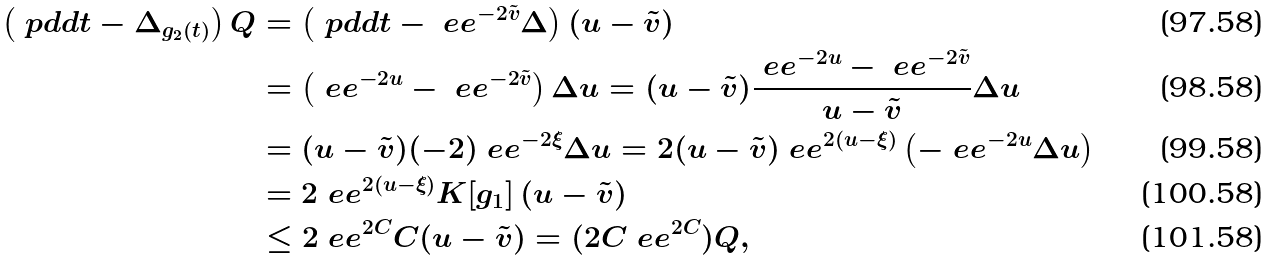<formula> <loc_0><loc_0><loc_500><loc_500>\left ( \ p d d t - \Delta _ { g _ { 2 } ( t ) } \right ) Q & = \left ( \ p d d t - \ e e ^ { - 2 \tilde { v } } \Delta \right ) ( u - \tilde { v } ) \\ & = \left ( \ e e ^ { - 2 u } - \ e e ^ { - 2 \tilde { v } } \right ) \Delta u = ( u - \tilde { v } ) \frac { \ e e ^ { - 2 u } - \ e e ^ { - 2 \tilde { v } } } { u - \tilde { v } } \Delta u \\ & = ( u - \tilde { v } ) ( - 2 ) \ e e ^ { - 2 \xi } \Delta u = 2 ( u - \tilde { v } ) \ e e ^ { 2 ( u - \xi ) } \left ( - \ e e ^ { - 2 u } \Delta u \right ) \\ & = 2 \ e e ^ { 2 ( u - \xi ) } K [ g _ { 1 } ] \, ( u - \tilde { v } ) \\ & \leq 2 \ e e ^ { 2 C } C ( u - \tilde { v } ) = ( 2 C \ e e ^ { 2 C } ) Q ,</formula> 